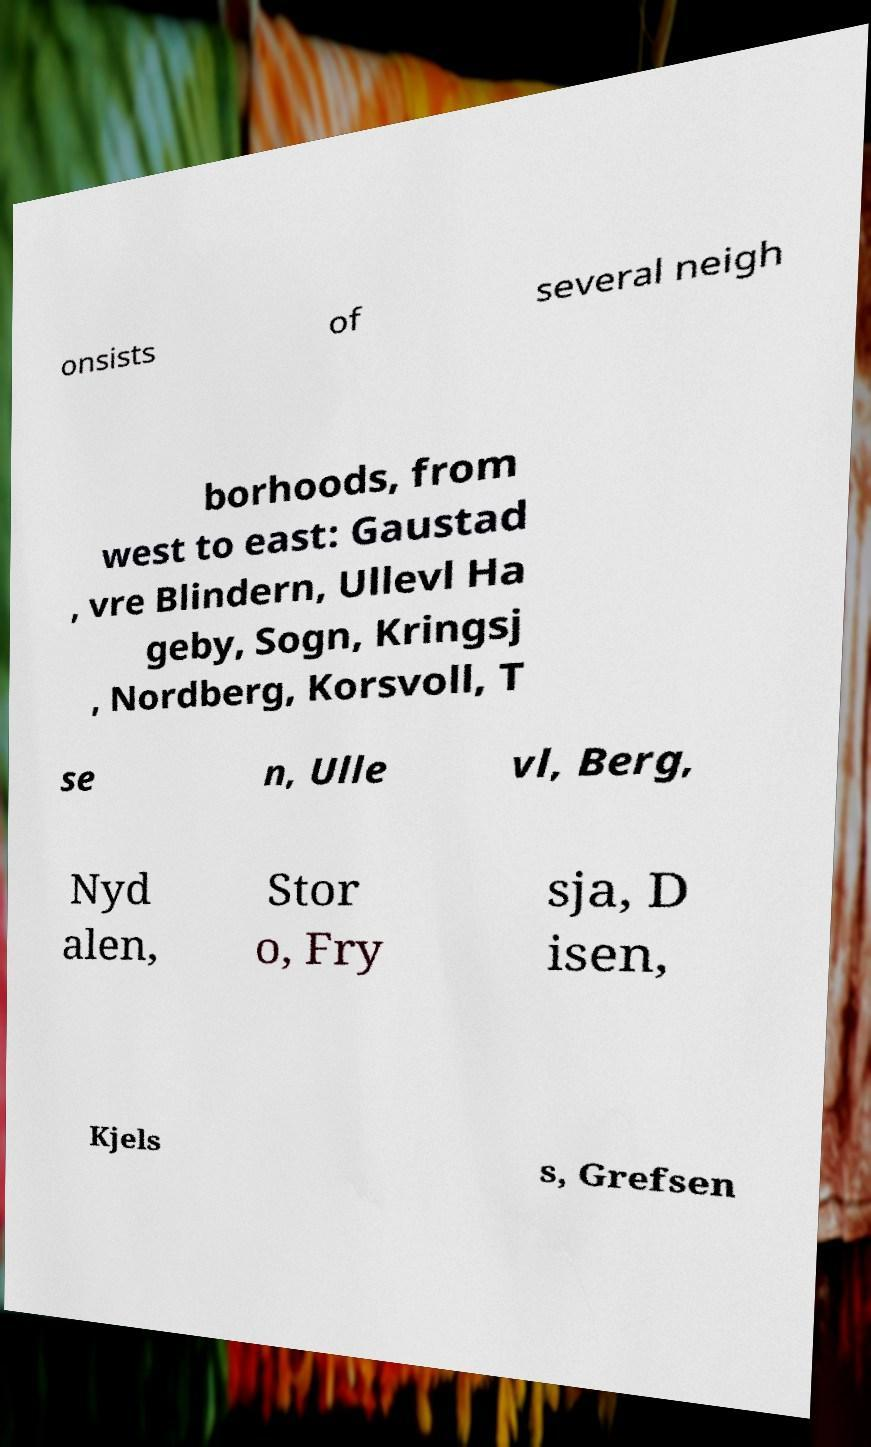Please read and relay the text visible in this image. What does it say? onsists of several neigh borhoods, from west to east: Gaustad , vre Blindern, Ullevl Ha geby, Sogn, Kringsj , Nordberg, Korsvoll, T se n, Ulle vl, Berg, Nyd alen, Stor o, Fry sja, D isen, Kjels s, Grefsen 